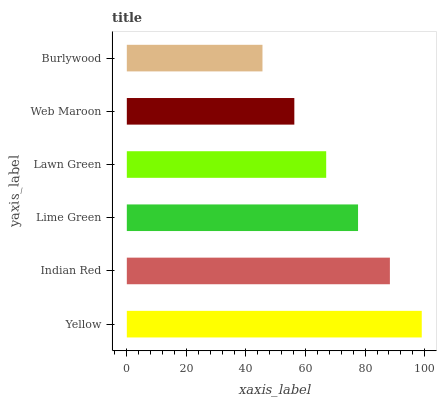Is Burlywood the minimum?
Answer yes or no. Yes. Is Yellow the maximum?
Answer yes or no. Yes. Is Indian Red the minimum?
Answer yes or no. No. Is Indian Red the maximum?
Answer yes or no. No. Is Yellow greater than Indian Red?
Answer yes or no. Yes. Is Indian Red less than Yellow?
Answer yes or no. Yes. Is Indian Red greater than Yellow?
Answer yes or no. No. Is Yellow less than Indian Red?
Answer yes or no. No. Is Lime Green the high median?
Answer yes or no. Yes. Is Lawn Green the low median?
Answer yes or no. Yes. Is Lawn Green the high median?
Answer yes or no. No. Is Burlywood the low median?
Answer yes or no. No. 